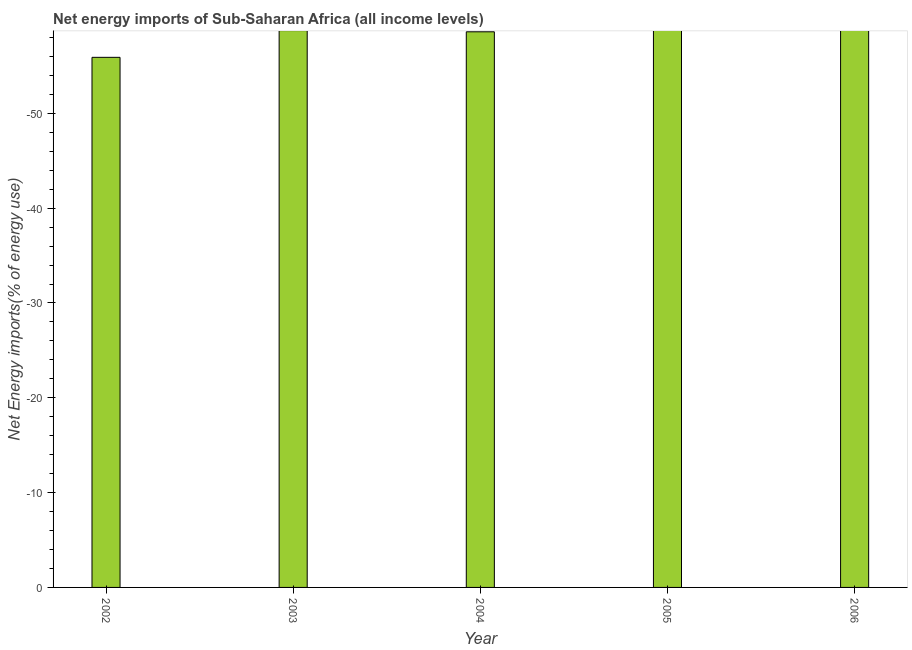What is the title of the graph?
Your response must be concise. Net energy imports of Sub-Saharan Africa (all income levels). What is the label or title of the Y-axis?
Keep it short and to the point. Net Energy imports(% of energy use). Across all years, what is the minimum energy imports?
Ensure brevity in your answer.  0. What is the sum of the energy imports?
Offer a very short reply. 0. How many bars are there?
Your answer should be very brief. 0. Are all the bars in the graph horizontal?
Ensure brevity in your answer.  No. Are the values on the major ticks of Y-axis written in scientific E-notation?
Give a very brief answer. No. What is the Net Energy imports(% of energy use) of 2002?
Make the answer very short. 0. What is the Net Energy imports(% of energy use) of 2003?
Your answer should be compact. 0. 